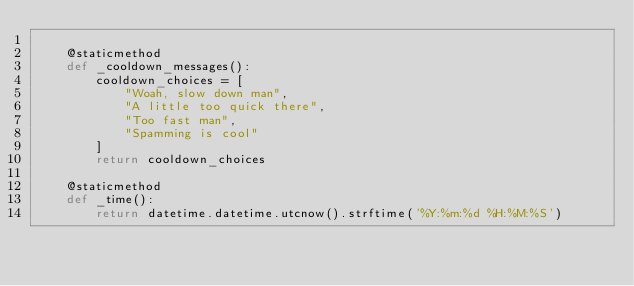Convert code to text. <code><loc_0><loc_0><loc_500><loc_500><_Python_>
    @staticmethod
    def _cooldown_messages():
        cooldown_choices = [
            "Woah, slow down man",
            "A little too quick there",
            "Too fast man",
            "Spamming is cool"
        ]
        return cooldown_choices

    @staticmethod
    def _time():
        return datetime.datetime.utcnow().strftime('%Y:%m:%d %H:%M:%S')
</code> 